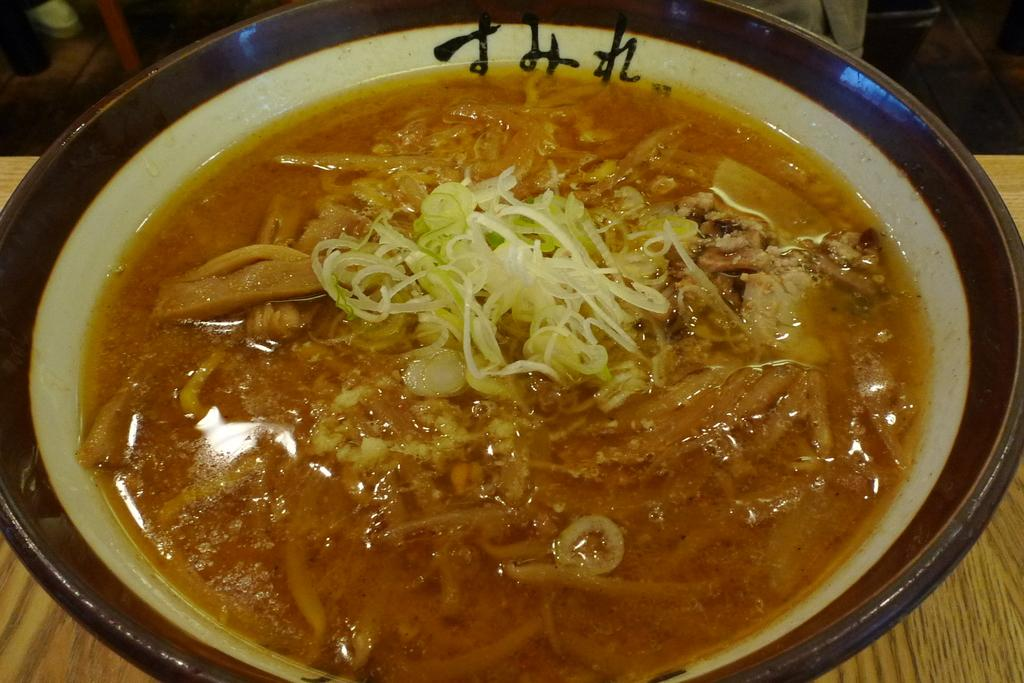What is in the bowl that is visible in the image? There is a bowl with food in the image. Where is the bowl located in the image? The bowl is placed on a table. What can be seen in the background of the image? There are objects visible in the background of the image. Is the grandfather playing a game of soccer in the field in the image? There is no mention of a grandfather or a field in the image, so we cannot confirm or deny the presence of a soccer game. 